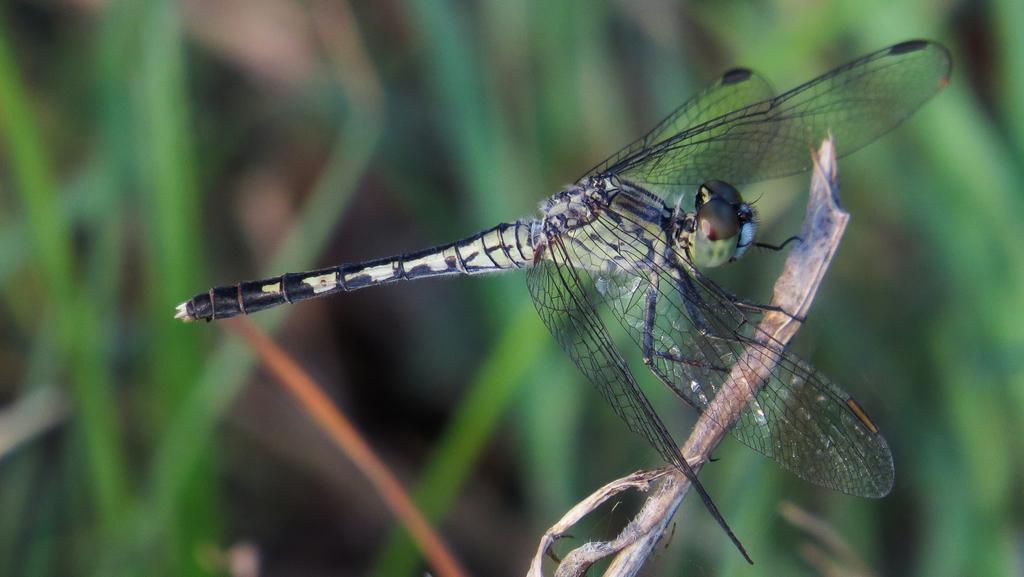Describe this image in one or two sentences. In this image I can see the dragonfly which is in black and green color. It is on the plant. And there is a blurred background. 